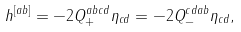Convert formula to latex. <formula><loc_0><loc_0><loc_500><loc_500>h ^ { [ a b ] } = - 2 Q _ { + } ^ { a b c d } \eta _ { c d } = - 2 Q _ { - } ^ { c d a b } \eta _ { c d } ,</formula> 